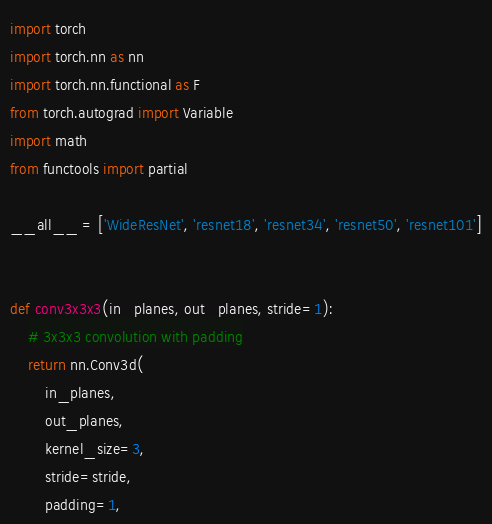<code> <loc_0><loc_0><loc_500><loc_500><_Python_>import torch
import torch.nn as nn
import torch.nn.functional as F
from torch.autograd import Variable
import math
from functools import partial

__all__ = ['WideResNet', 'resnet18', 'resnet34', 'resnet50', 'resnet101']


def conv3x3x3(in_planes, out_planes, stride=1):
    # 3x3x3 convolution with padding
    return nn.Conv3d(
        in_planes,
        out_planes,
        kernel_size=3,
        stride=stride,
        padding=1,</code> 